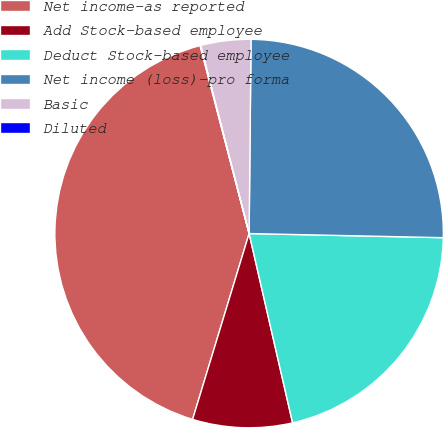Convert chart. <chart><loc_0><loc_0><loc_500><loc_500><pie_chart><fcel>Net income-as reported<fcel>Add Stock-based employee<fcel>Deduct Stock-based employee<fcel>Net income (loss)-pro forma<fcel>Basic<fcel>Diluted<nl><fcel>41.24%<fcel>8.29%<fcel>21.07%<fcel>25.18%<fcel>4.17%<fcel>0.05%<nl></chart> 